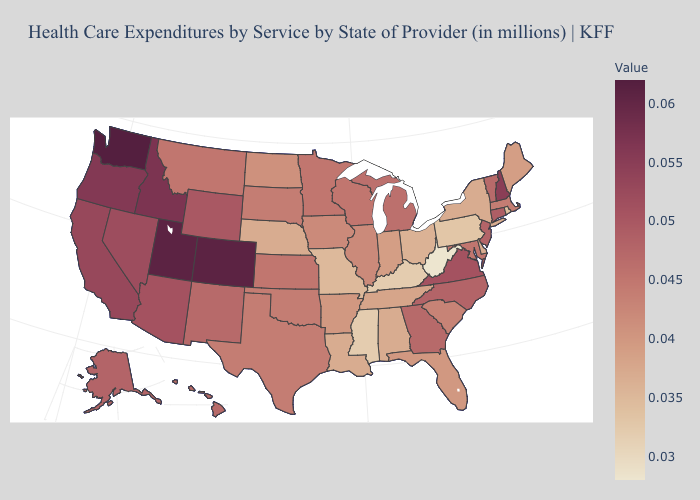Among the states that border West Virginia , does Kentucky have the highest value?
Short answer required. No. Which states have the highest value in the USA?
Be succinct. Washington. 